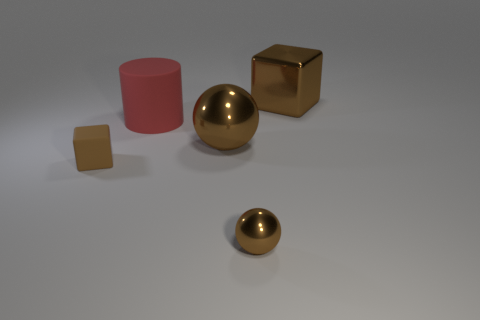What material is the thing right of the brown ball on the right side of the large sphere?
Your response must be concise. Metal. Is there a tiny brown object that has the same material as the cylinder?
Your answer should be compact. Yes. The tiny object to the right of the block in front of the brown block behind the rubber cube is what shape?
Your answer should be very brief. Sphere. What material is the large red thing?
Keep it short and to the point. Rubber. There is a large block that is made of the same material as the small brown sphere; what color is it?
Make the answer very short. Brown. Is there a ball behind the brown block left of the large rubber thing?
Ensure brevity in your answer.  Yes. What number of other things are the same shape as the tiny brown shiny object?
Make the answer very short. 1. There is a small object that is in front of the tiny brown rubber block; is it the same shape as the large metallic object in front of the large cube?
Offer a very short reply. Yes. What number of large red matte things are to the left of the big brown thing that is in front of the large thing behind the large red thing?
Ensure brevity in your answer.  1. The tiny metal thing has what color?
Keep it short and to the point. Brown. 